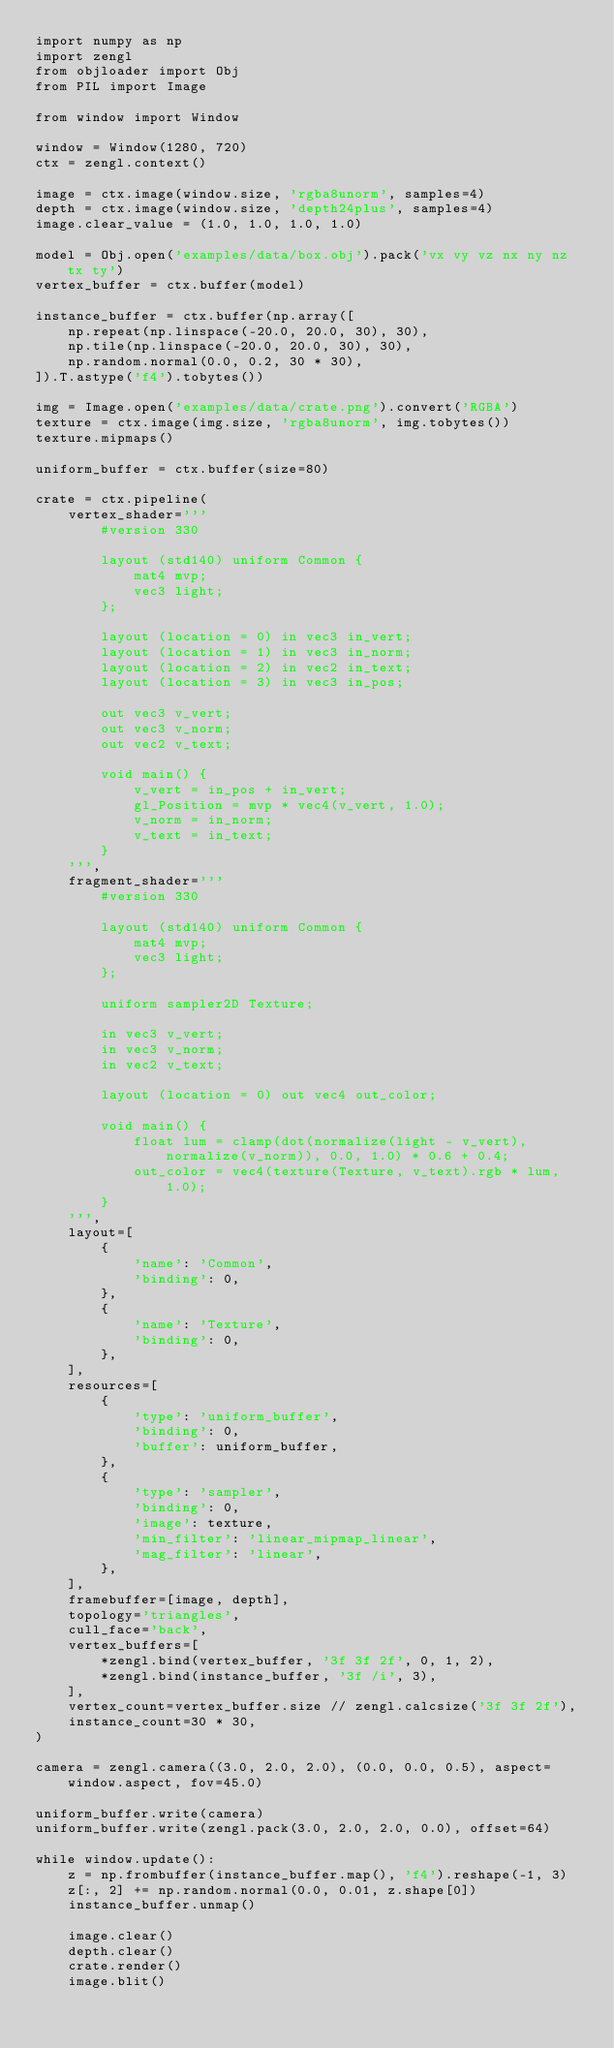Convert code to text. <code><loc_0><loc_0><loc_500><loc_500><_Python_>import numpy as np
import zengl
from objloader import Obj
from PIL import Image

from window import Window

window = Window(1280, 720)
ctx = zengl.context()

image = ctx.image(window.size, 'rgba8unorm', samples=4)
depth = ctx.image(window.size, 'depth24plus', samples=4)
image.clear_value = (1.0, 1.0, 1.0, 1.0)

model = Obj.open('examples/data/box.obj').pack('vx vy vz nx ny nz tx ty')
vertex_buffer = ctx.buffer(model)

instance_buffer = ctx.buffer(np.array([
    np.repeat(np.linspace(-20.0, 20.0, 30), 30),
    np.tile(np.linspace(-20.0, 20.0, 30), 30),
    np.random.normal(0.0, 0.2, 30 * 30),
]).T.astype('f4').tobytes())

img = Image.open('examples/data/crate.png').convert('RGBA')
texture = ctx.image(img.size, 'rgba8unorm', img.tobytes())
texture.mipmaps()

uniform_buffer = ctx.buffer(size=80)

crate = ctx.pipeline(
    vertex_shader='''
        #version 330

        layout (std140) uniform Common {
            mat4 mvp;
            vec3 light;
        };

        layout (location = 0) in vec3 in_vert;
        layout (location = 1) in vec3 in_norm;
        layout (location = 2) in vec2 in_text;
        layout (location = 3) in vec3 in_pos;

        out vec3 v_vert;
        out vec3 v_norm;
        out vec2 v_text;

        void main() {
            v_vert = in_pos + in_vert;
            gl_Position = mvp * vec4(v_vert, 1.0);
            v_norm = in_norm;
            v_text = in_text;
        }
    ''',
    fragment_shader='''
        #version 330

        layout (std140) uniform Common {
            mat4 mvp;
            vec3 light;
        };

        uniform sampler2D Texture;

        in vec3 v_vert;
        in vec3 v_norm;
        in vec2 v_text;

        layout (location = 0) out vec4 out_color;

        void main() {
            float lum = clamp(dot(normalize(light - v_vert), normalize(v_norm)), 0.0, 1.0) * 0.6 + 0.4;
            out_color = vec4(texture(Texture, v_text).rgb * lum, 1.0);
        }
    ''',
    layout=[
        {
            'name': 'Common',
            'binding': 0,
        },
        {
            'name': 'Texture',
            'binding': 0,
        },
    ],
    resources=[
        {
            'type': 'uniform_buffer',
            'binding': 0,
            'buffer': uniform_buffer,
        },
        {
            'type': 'sampler',
            'binding': 0,
            'image': texture,
            'min_filter': 'linear_mipmap_linear',
            'mag_filter': 'linear',
        },
    ],
    framebuffer=[image, depth],
    topology='triangles',
    cull_face='back',
    vertex_buffers=[
        *zengl.bind(vertex_buffer, '3f 3f 2f', 0, 1, 2),
        *zengl.bind(instance_buffer, '3f /i', 3),
    ],
    vertex_count=vertex_buffer.size // zengl.calcsize('3f 3f 2f'),
    instance_count=30 * 30,
)

camera = zengl.camera((3.0, 2.0, 2.0), (0.0, 0.0, 0.5), aspect=window.aspect, fov=45.0)

uniform_buffer.write(camera)
uniform_buffer.write(zengl.pack(3.0, 2.0, 2.0, 0.0), offset=64)

while window.update():
    z = np.frombuffer(instance_buffer.map(), 'f4').reshape(-1, 3)
    z[:, 2] += np.random.normal(0.0, 0.01, z.shape[0])
    instance_buffer.unmap()

    image.clear()
    depth.clear()
    crate.render()
    image.blit()
</code> 